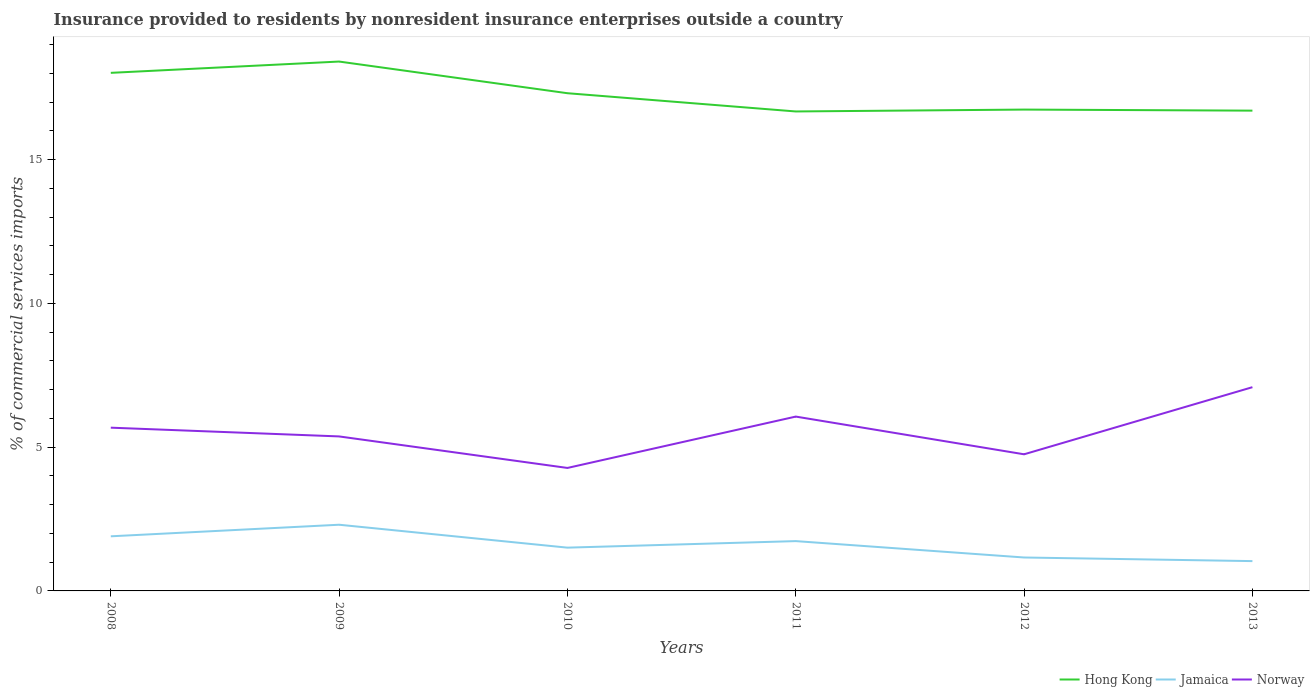How many different coloured lines are there?
Provide a short and direct response. 3. Is the number of lines equal to the number of legend labels?
Ensure brevity in your answer.  Yes. Across all years, what is the maximum Insurance provided to residents in Hong Kong?
Ensure brevity in your answer.  16.68. What is the total Insurance provided to residents in Hong Kong in the graph?
Make the answer very short. 0.61. What is the difference between the highest and the second highest Insurance provided to residents in Norway?
Your response must be concise. 2.81. How many years are there in the graph?
Make the answer very short. 6. Are the values on the major ticks of Y-axis written in scientific E-notation?
Offer a terse response. No. Does the graph contain any zero values?
Ensure brevity in your answer.  No. Where does the legend appear in the graph?
Keep it short and to the point. Bottom right. How many legend labels are there?
Your answer should be very brief. 3. How are the legend labels stacked?
Provide a succinct answer. Horizontal. What is the title of the graph?
Offer a very short reply. Insurance provided to residents by nonresident insurance enterprises outside a country. What is the label or title of the X-axis?
Your response must be concise. Years. What is the label or title of the Y-axis?
Keep it short and to the point. % of commercial services imports. What is the % of commercial services imports in Hong Kong in 2008?
Give a very brief answer. 18.02. What is the % of commercial services imports in Jamaica in 2008?
Provide a short and direct response. 1.9. What is the % of commercial services imports in Norway in 2008?
Keep it short and to the point. 5.68. What is the % of commercial services imports of Hong Kong in 2009?
Ensure brevity in your answer.  18.41. What is the % of commercial services imports of Jamaica in 2009?
Offer a terse response. 2.3. What is the % of commercial services imports in Norway in 2009?
Provide a succinct answer. 5.37. What is the % of commercial services imports in Hong Kong in 2010?
Provide a short and direct response. 17.31. What is the % of commercial services imports of Jamaica in 2010?
Give a very brief answer. 1.51. What is the % of commercial services imports of Norway in 2010?
Ensure brevity in your answer.  4.28. What is the % of commercial services imports in Hong Kong in 2011?
Make the answer very short. 16.68. What is the % of commercial services imports of Jamaica in 2011?
Make the answer very short. 1.73. What is the % of commercial services imports of Norway in 2011?
Your response must be concise. 6.06. What is the % of commercial services imports of Hong Kong in 2012?
Ensure brevity in your answer.  16.74. What is the % of commercial services imports in Jamaica in 2012?
Your answer should be compact. 1.16. What is the % of commercial services imports in Norway in 2012?
Your answer should be compact. 4.75. What is the % of commercial services imports of Hong Kong in 2013?
Give a very brief answer. 16.7. What is the % of commercial services imports in Jamaica in 2013?
Your answer should be compact. 1.04. What is the % of commercial services imports of Norway in 2013?
Give a very brief answer. 7.09. Across all years, what is the maximum % of commercial services imports of Hong Kong?
Provide a short and direct response. 18.41. Across all years, what is the maximum % of commercial services imports of Jamaica?
Make the answer very short. 2.3. Across all years, what is the maximum % of commercial services imports of Norway?
Give a very brief answer. 7.09. Across all years, what is the minimum % of commercial services imports of Hong Kong?
Offer a terse response. 16.68. Across all years, what is the minimum % of commercial services imports in Jamaica?
Provide a succinct answer. 1.04. Across all years, what is the minimum % of commercial services imports in Norway?
Your answer should be very brief. 4.28. What is the total % of commercial services imports in Hong Kong in the graph?
Your answer should be very brief. 103.86. What is the total % of commercial services imports of Jamaica in the graph?
Offer a very short reply. 9.64. What is the total % of commercial services imports in Norway in the graph?
Offer a very short reply. 33.23. What is the difference between the % of commercial services imports of Hong Kong in 2008 and that in 2009?
Your answer should be very brief. -0.39. What is the difference between the % of commercial services imports in Jamaica in 2008 and that in 2009?
Your response must be concise. -0.4. What is the difference between the % of commercial services imports of Norway in 2008 and that in 2009?
Your answer should be compact. 0.3. What is the difference between the % of commercial services imports of Hong Kong in 2008 and that in 2010?
Give a very brief answer. 0.71. What is the difference between the % of commercial services imports of Jamaica in 2008 and that in 2010?
Offer a terse response. 0.39. What is the difference between the % of commercial services imports of Norway in 2008 and that in 2010?
Your answer should be compact. 1.4. What is the difference between the % of commercial services imports in Hong Kong in 2008 and that in 2011?
Provide a succinct answer. 1.34. What is the difference between the % of commercial services imports of Jamaica in 2008 and that in 2011?
Provide a short and direct response. 0.17. What is the difference between the % of commercial services imports in Norway in 2008 and that in 2011?
Offer a very short reply. -0.39. What is the difference between the % of commercial services imports in Hong Kong in 2008 and that in 2012?
Provide a short and direct response. 1.28. What is the difference between the % of commercial services imports in Jamaica in 2008 and that in 2012?
Provide a short and direct response. 0.74. What is the difference between the % of commercial services imports of Norway in 2008 and that in 2012?
Offer a terse response. 0.93. What is the difference between the % of commercial services imports in Hong Kong in 2008 and that in 2013?
Offer a terse response. 1.31. What is the difference between the % of commercial services imports in Jamaica in 2008 and that in 2013?
Give a very brief answer. 0.86. What is the difference between the % of commercial services imports in Norway in 2008 and that in 2013?
Give a very brief answer. -1.41. What is the difference between the % of commercial services imports of Hong Kong in 2009 and that in 2010?
Ensure brevity in your answer.  1.1. What is the difference between the % of commercial services imports of Jamaica in 2009 and that in 2010?
Make the answer very short. 0.8. What is the difference between the % of commercial services imports of Norway in 2009 and that in 2010?
Your answer should be compact. 1.1. What is the difference between the % of commercial services imports of Hong Kong in 2009 and that in 2011?
Your answer should be very brief. 1.74. What is the difference between the % of commercial services imports of Jamaica in 2009 and that in 2011?
Make the answer very short. 0.57. What is the difference between the % of commercial services imports of Norway in 2009 and that in 2011?
Keep it short and to the point. -0.69. What is the difference between the % of commercial services imports in Hong Kong in 2009 and that in 2012?
Provide a short and direct response. 1.67. What is the difference between the % of commercial services imports of Jamaica in 2009 and that in 2012?
Give a very brief answer. 1.14. What is the difference between the % of commercial services imports in Norway in 2009 and that in 2012?
Provide a short and direct response. 0.62. What is the difference between the % of commercial services imports in Hong Kong in 2009 and that in 2013?
Provide a succinct answer. 1.71. What is the difference between the % of commercial services imports of Jamaica in 2009 and that in 2013?
Provide a short and direct response. 1.26. What is the difference between the % of commercial services imports in Norway in 2009 and that in 2013?
Offer a very short reply. -1.71. What is the difference between the % of commercial services imports in Hong Kong in 2010 and that in 2011?
Make the answer very short. 0.63. What is the difference between the % of commercial services imports of Jamaica in 2010 and that in 2011?
Your answer should be very brief. -0.23. What is the difference between the % of commercial services imports in Norway in 2010 and that in 2011?
Your response must be concise. -1.79. What is the difference between the % of commercial services imports in Hong Kong in 2010 and that in 2012?
Your answer should be compact. 0.57. What is the difference between the % of commercial services imports in Jamaica in 2010 and that in 2012?
Your answer should be very brief. 0.34. What is the difference between the % of commercial services imports in Norway in 2010 and that in 2012?
Your response must be concise. -0.47. What is the difference between the % of commercial services imports in Hong Kong in 2010 and that in 2013?
Your answer should be compact. 0.61. What is the difference between the % of commercial services imports in Jamaica in 2010 and that in 2013?
Your answer should be very brief. 0.47. What is the difference between the % of commercial services imports in Norway in 2010 and that in 2013?
Provide a succinct answer. -2.81. What is the difference between the % of commercial services imports in Hong Kong in 2011 and that in 2012?
Keep it short and to the point. -0.07. What is the difference between the % of commercial services imports in Jamaica in 2011 and that in 2012?
Offer a very short reply. 0.57. What is the difference between the % of commercial services imports in Norway in 2011 and that in 2012?
Offer a very short reply. 1.31. What is the difference between the % of commercial services imports of Hong Kong in 2011 and that in 2013?
Your answer should be very brief. -0.03. What is the difference between the % of commercial services imports in Jamaica in 2011 and that in 2013?
Provide a succinct answer. 0.7. What is the difference between the % of commercial services imports in Norway in 2011 and that in 2013?
Provide a succinct answer. -1.02. What is the difference between the % of commercial services imports of Hong Kong in 2012 and that in 2013?
Provide a succinct answer. 0.04. What is the difference between the % of commercial services imports of Jamaica in 2012 and that in 2013?
Your response must be concise. 0.13. What is the difference between the % of commercial services imports of Norway in 2012 and that in 2013?
Provide a short and direct response. -2.33. What is the difference between the % of commercial services imports of Hong Kong in 2008 and the % of commercial services imports of Jamaica in 2009?
Provide a short and direct response. 15.72. What is the difference between the % of commercial services imports of Hong Kong in 2008 and the % of commercial services imports of Norway in 2009?
Provide a short and direct response. 12.65. What is the difference between the % of commercial services imports of Jamaica in 2008 and the % of commercial services imports of Norway in 2009?
Your answer should be compact. -3.47. What is the difference between the % of commercial services imports of Hong Kong in 2008 and the % of commercial services imports of Jamaica in 2010?
Make the answer very short. 16.51. What is the difference between the % of commercial services imports in Hong Kong in 2008 and the % of commercial services imports in Norway in 2010?
Offer a very short reply. 13.74. What is the difference between the % of commercial services imports in Jamaica in 2008 and the % of commercial services imports in Norway in 2010?
Ensure brevity in your answer.  -2.38. What is the difference between the % of commercial services imports in Hong Kong in 2008 and the % of commercial services imports in Jamaica in 2011?
Your answer should be compact. 16.29. What is the difference between the % of commercial services imports in Hong Kong in 2008 and the % of commercial services imports in Norway in 2011?
Offer a terse response. 11.96. What is the difference between the % of commercial services imports in Jamaica in 2008 and the % of commercial services imports in Norway in 2011?
Your response must be concise. -4.16. What is the difference between the % of commercial services imports of Hong Kong in 2008 and the % of commercial services imports of Jamaica in 2012?
Your answer should be very brief. 16.86. What is the difference between the % of commercial services imports in Hong Kong in 2008 and the % of commercial services imports in Norway in 2012?
Make the answer very short. 13.27. What is the difference between the % of commercial services imports of Jamaica in 2008 and the % of commercial services imports of Norway in 2012?
Give a very brief answer. -2.85. What is the difference between the % of commercial services imports in Hong Kong in 2008 and the % of commercial services imports in Jamaica in 2013?
Offer a terse response. 16.98. What is the difference between the % of commercial services imports of Hong Kong in 2008 and the % of commercial services imports of Norway in 2013?
Your answer should be very brief. 10.93. What is the difference between the % of commercial services imports of Jamaica in 2008 and the % of commercial services imports of Norway in 2013?
Offer a terse response. -5.19. What is the difference between the % of commercial services imports of Hong Kong in 2009 and the % of commercial services imports of Jamaica in 2010?
Offer a very short reply. 16.91. What is the difference between the % of commercial services imports in Hong Kong in 2009 and the % of commercial services imports in Norway in 2010?
Provide a short and direct response. 14.13. What is the difference between the % of commercial services imports in Jamaica in 2009 and the % of commercial services imports in Norway in 2010?
Keep it short and to the point. -1.98. What is the difference between the % of commercial services imports of Hong Kong in 2009 and the % of commercial services imports of Jamaica in 2011?
Provide a succinct answer. 16.68. What is the difference between the % of commercial services imports of Hong Kong in 2009 and the % of commercial services imports of Norway in 2011?
Ensure brevity in your answer.  12.35. What is the difference between the % of commercial services imports of Jamaica in 2009 and the % of commercial services imports of Norway in 2011?
Provide a succinct answer. -3.76. What is the difference between the % of commercial services imports of Hong Kong in 2009 and the % of commercial services imports of Jamaica in 2012?
Provide a succinct answer. 17.25. What is the difference between the % of commercial services imports in Hong Kong in 2009 and the % of commercial services imports in Norway in 2012?
Provide a succinct answer. 13.66. What is the difference between the % of commercial services imports in Jamaica in 2009 and the % of commercial services imports in Norway in 2012?
Give a very brief answer. -2.45. What is the difference between the % of commercial services imports in Hong Kong in 2009 and the % of commercial services imports in Jamaica in 2013?
Your response must be concise. 17.37. What is the difference between the % of commercial services imports in Hong Kong in 2009 and the % of commercial services imports in Norway in 2013?
Make the answer very short. 11.32. What is the difference between the % of commercial services imports in Jamaica in 2009 and the % of commercial services imports in Norway in 2013?
Your answer should be compact. -4.78. What is the difference between the % of commercial services imports in Hong Kong in 2010 and the % of commercial services imports in Jamaica in 2011?
Provide a succinct answer. 15.58. What is the difference between the % of commercial services imports of Hong Kong in 2010 and the % of commercial services imports of Norway in 2011?
Make the answer very short. 11.25. What is the difference between the % of commercial services imports of Jamaica in 2010 and the % of commercial services imports of Norway in 2011?
Provide a succinct answer. -4.56. What is the difference between the % of commercial services imports in Hong Kong in 2010 and the % of commercial services imports in Jamaica in 2012?
Offer a terse response. 16.15. What is the difference between the % of commercial services imports of Hong Kong in 2010 and the % of commercial services imports of Norway in 2012?
Provide a short and direct response. 12.56. What is the difference between the % of commercial services imports in Jamaica in 2010 and the % of commercial services imports in Norway in 2012?
Your response must be concise. -3.25. What is the difference between the % of commercial services imports of Hong Kong in 2010 and the % of commercial services imports of Jamaica in 2013?
Provide a succinct answer. 16.27. What is the difference between the % of commercial services imports of Hong Kong in 2010 and the % of commercial services imports of Norway in 2013?
Your response must be concise. 10.22. What is the difference between the % of commercial services imports in Jamaica in 2010 and the % of commercial services imports in Norway in 2013?
Ensure brevity in your answer.  -5.58. What is the difference between the % of commercial services imports of Hong Kong in 2011 and the % of commercial services imports of Jamaica in 2012?
Provide a short and direct response. 15.51. What is the difference between the % of commercial services imports in Hong Kong in 2011 and the % of commercial services imports in Norway in 2012?
Provide a succinct answer. 11.92. What is the difference between the % of commercial services imports of Jamaica in 2011 and the % of commercial services imports of Norway in 2012?
Provide a succinct answer. -3.02. What is the difference between the % of commercial services imports in Hong Kong in 2011 and the % of commercial services imports in Jamaica in 2013?
Your response must be concise. 15.64. What is the difference between the % of commercial services imports of Hong Kong in 2011 and the % of commercial services imports of Norway in 2013?
Your answer should be compact. 9.59. What is the difference between the % of commercial services imports in Jamaica in 2011 and the % of commercial services imports in Norway in 2013?
Provide a short and direct response. -5.35. What is the difference between the % of commercial services imports in Hong Kong in 2012 and the % of commercial services imports in Jamaica in 2013?
Offer a very short reply. 15.7. What is the difference between the % of commercial services imports of Hong Kong in 2012 and the % of commercial services imports of Norway in 2013?
Keep it short and to the point. 9.65. What is the difference between the % of commercial services imports in Jamaica in 2012 and the % of commercial services imports in Norway in 2013?
Your answer should be very brief. -5.92. What is the average % of commercial services imports in Hong Kong per year?
Provide a short and direct response. 17.31. What is the average % of commercial services imports in Jamaica per year?
Give a very brief answer. 1.61. What is the average % of commercial services imports of Norway per year?
Ensure brevity in your answer.  5.54. In the year 2008, what is the difference between the % of commercial services imports of Hong Kong and % of commercial services imports of Jamaica?
Keep it short and to the point. 16.12. In the year 2008, what is the difference between the % of commercial services imports in Hong Kong and % of commercial services imports in Norway?
Provide a succinct answer. 12.34. In the year 2008, what is the difference between the % of commercial services imports of Jamaica and % of commercial services imports of Norway?
Ensure brevity in your answer.  -3.78. In the year 2009, what is the difference between the % of commercial services imports of Hong Kong and % of commercial services imports of Jamaica?
Provide a succinct answer. 16.11. In the year 2009, what is the difference between the % of commercial services imports in Hong Kong and % of commercial services imports in Norway?
Give a very brief answer. 13.04. In the year 2009, what is the difference between the % of commercial services imports of Jamaica and % of commercial services imports of Norway?
Provide a short and direct response. -3.07. In the year 2010, what is the difference between the % of commercial services imports in Hong Kong and % of commercial services imports in Jamaica?
Provide a short and direct response. 15.8. In the year 2010, what is the difference between the % of commercial services imports in Hong Kong and % of commercial services imports in Norway?
Your answer should be compact. 13.03. In the year 2010, what is the difference between the % of commercial services imports of Jamaica and % of commercial services imports of Norway?
Your answer should be very brief. -2.77. In the year 2011, what is the difference between the % of commercial services imports of Hong Kong and % of commercial services imports of Jamaica?
Offer a very short reply. 14.94. In the year 2011, what is the difference between the % of commercial services imports of Hong Kong and % of commercial services imports of Norway?
Give a very brief answer. 10.61. In the year 2011, what is the difference between the % of commercial services imports of Jamaica and % of commercial services imports of Norway?
Your response must be concise. -4.33. In the year 2012, what is the difference between the % of commercial services imports in Hong Kong and % of commercial services imports in Jamaica?
Provide a short and direct response. 15.58. In the year 2012, what is the difference between the % of commercial services imports in Hong Kong and % of commercial services imports in Norway?
Keep it short and to the point. 11.99. In the year 2012, what is the difference between the % of commercial services imports in Jamaica and % of commercial services imports in Norway?
Make the answer very short. -3.59. In the year 2013, what is the difference between the % of commercial services imports in Hong Kong and % of commercial services imports in Jamaica?
Give a very brief answer. 15.67. In the year 2013, what is the difference between the % of commercial services imports in Hong Kong and % of commercial services imports in Norway?
Offer a very short reply. 9.62. In the year 2013, what is the difference between the % of commercial services imports of Jamaica and % of commercial services imports of Norway?
Make the answer very short. -6.05. What is the ratio of the % of commercial services imports in Hong Kong in 2008 to that in 2009?
Offer a terse response. 0.98. What is the ratio of the % of commercial services imports in Jamaica in 2008 to that in 2009?
Your answer should be compact. 0.83. What is the ratio of the % of commercial services imports of Norway in 2008 to that in 2009?
Provide a short and direct response. 1.06. What is the ratio of the % of commercial services imports in Hong Kong in 2008 to that in 2010?
Keep it short and to the point. 1.04. What is the ratio of the % of commercial services imports of Jamaica in 2008 to that in 2010?
Give a very brief answer. 1.26. What is the ratio of the % of commercial services imports of Norway in 2008 to that in 2010?
Provide a short and direct response. 1.33. What is the ratio of the % of commercial services imports of Hong Kong in 2008 to that in 2011?
Offer a very short reply. 1.08. What is the ratio of the % of commercial services imports of Jamaica in 2008 to that in 2011?
Make the answer very short. 1.1. What is the ratio of the % of commercial services imports of Norway in 2008 to that in 2011?
Your response must be concise. 0.94. What is the ratio of the % of commercial services imports of Hong Kong in 2008 to that in 2012?
Give a very brief answer. 1.08. What is the ratio of the % of commercial services imports in Jamaica in 2008 to that in 2012?
Ensure brevity in your answer.  1.63. What is the ratio of the % of commercial services imports in Norway in 2008 to that in 2012?
Your response must be concise. 1.19. What is the ratio of the % of commercial services imports in Hong Kong in 2008 to that in 2013?
Offer a terse response. 1.08. What is the ratio of the % of commercial services imports of Jamaica in 2008 to that in 2013?
Your answer should be compact. 1.83. What is the ratio of the % of commercial services imports in Norway in 2008 to that in 2013?
Your response must be concise. 0.8. What is the ratio of the % of commercial services imports in Hong Kong in 2009 to that in 2010?
Keep it short and to the point. 1.06. What is the ratio of the % of commercial services imports of Jamaica in 2009 to that in 2010?
Your answer should be very brief. 1.53. What is the ratio of the % of commercial services imports in Norway in 2009 to that in 2010?
Your response must be concise. 1.26. What is the ratio of the % of commercial services imports of Hong Kong in 2009 to that in 2011?
Offer a terse response. 1.1. What is the ratio of the % of commercial services imports of Jamaica in 2009 to that in 2011?
Give a very brief answer. 1.33. What is the ratio of the % of commercial services imports in Norway in 2009 to that in 2011?
Provide a short and direct response. 0.89. What is the ratio of the % of commercial services imports in Hong Kong in 2009 to that in 2012?
Make the answer very short. 1.1. What is the ratio of the % of commercial services imports of Jamaica in 2009 to that in 2012?
Your answer should be very brief. 1.98. What is the ratio of the % of commercial services imports in Norway in 2009 to that in 2012?
Provide a succinct answer. 1.13. What is the ratio of the % of commercial services imports of Hong Kong in 2009 to that in 2013?
Keep it short and to the point. 1.1. What is the ratio of the % of commercial services imports of Jamaica in 2009 to that in 2013?
Provide a succinct answer. 2.22. What is the ratio of the % of commercial services imports of Norway in 2009 to that in 2013?
Your answer should be compact. 0.76. What is the ratio of the % of commercial services imports in Hong Kong in 2010 to that in 2011?
Provide a short and direct response. 1.04. What is the ratio of the % of commercial services imports of Jamaica in 2010 to that in 2011?
Ensure brevity in your answer.  0.87. What is the ratio of the % of commercial services imports of Norway in 2010 to that in 2011?
Give a very brief answer. 0.71. What is the ratio of the % of commercial services imports of Hong Kong in 2010 to that in 2012?
Make the answer very short. 1.03. What is the ratio of the % of commercial services imports in Jamaica in 2010 to that in 2012?
Keep it short and to the point. 1.29. What is the ratio of the % of commercial services imports in Norway in 2010 to that in 2012?
Your answer should be compact. 0.9. What is the ratio of the % of commercial services imports of Hong Kong in 2010 to that in 2013?
Offer a very short reply. 1.04. What is the ratio of the % of commercial services imports in Jamaica in 2010 to that in 2013?
Provide a succinct answer. 1.45. What is the ratio of the % of commercial services imports in Norway in 2010 to that in 2013?
Offer a terse response. 0.6. What is the ratio of the % of commercial services imports in Jamaica in 2011 to that in 2012?
Give a very brief answer. 1.49. What is the ratio of the % of commercial services imports in Norway in 2011 to that in 2012?
Offer a very short reply. 1.28. What is the ratio of the % of commercial services imports of Jamaica in 2011 to that in 2013?
Offer a very short reply. 1.67. What is the ratio of the % of commercial services imports of Norway in 2011 to that in 2013?
Give a very brief answer. 0.86. What is the ratio of the % of commercial services imports of Hong Kong in 2012 to that in 2013?
Give a very brief answer. 1. What is the ratio of the % of commercial services imports of Jamaica in 2012 to that in 2013?
Make the answer very short. 1.12. What is the ratio of the % of commercial services imports in Norway in 2012 to that in 2013?
Your answer should be very brief. 0.67. What is the difference between the highest and the second highest % of commercial services imports of Hong Kong?
Provide a short and direct response. 0.39. What is the difference between the highest and the second highest % of commercial services imports of Jamaica?
Make the answer very short. 0.4. What is the difference between the highest and the second highest % of commercial services imports in Norway?
Your answer should be very brief. 1.02. What is the difference between the highest and the lowest % of commercial services imports of Hong Kong?
Offer a very short reply. 1.74. What is the difference between the highest and the lowest % of commercial services imports in Jamaica?
Your response must be concise. 1.26. What is the difference between the highest and the lowest % of commercial services imports of Norway?
Offer a terse response. 2.81. 